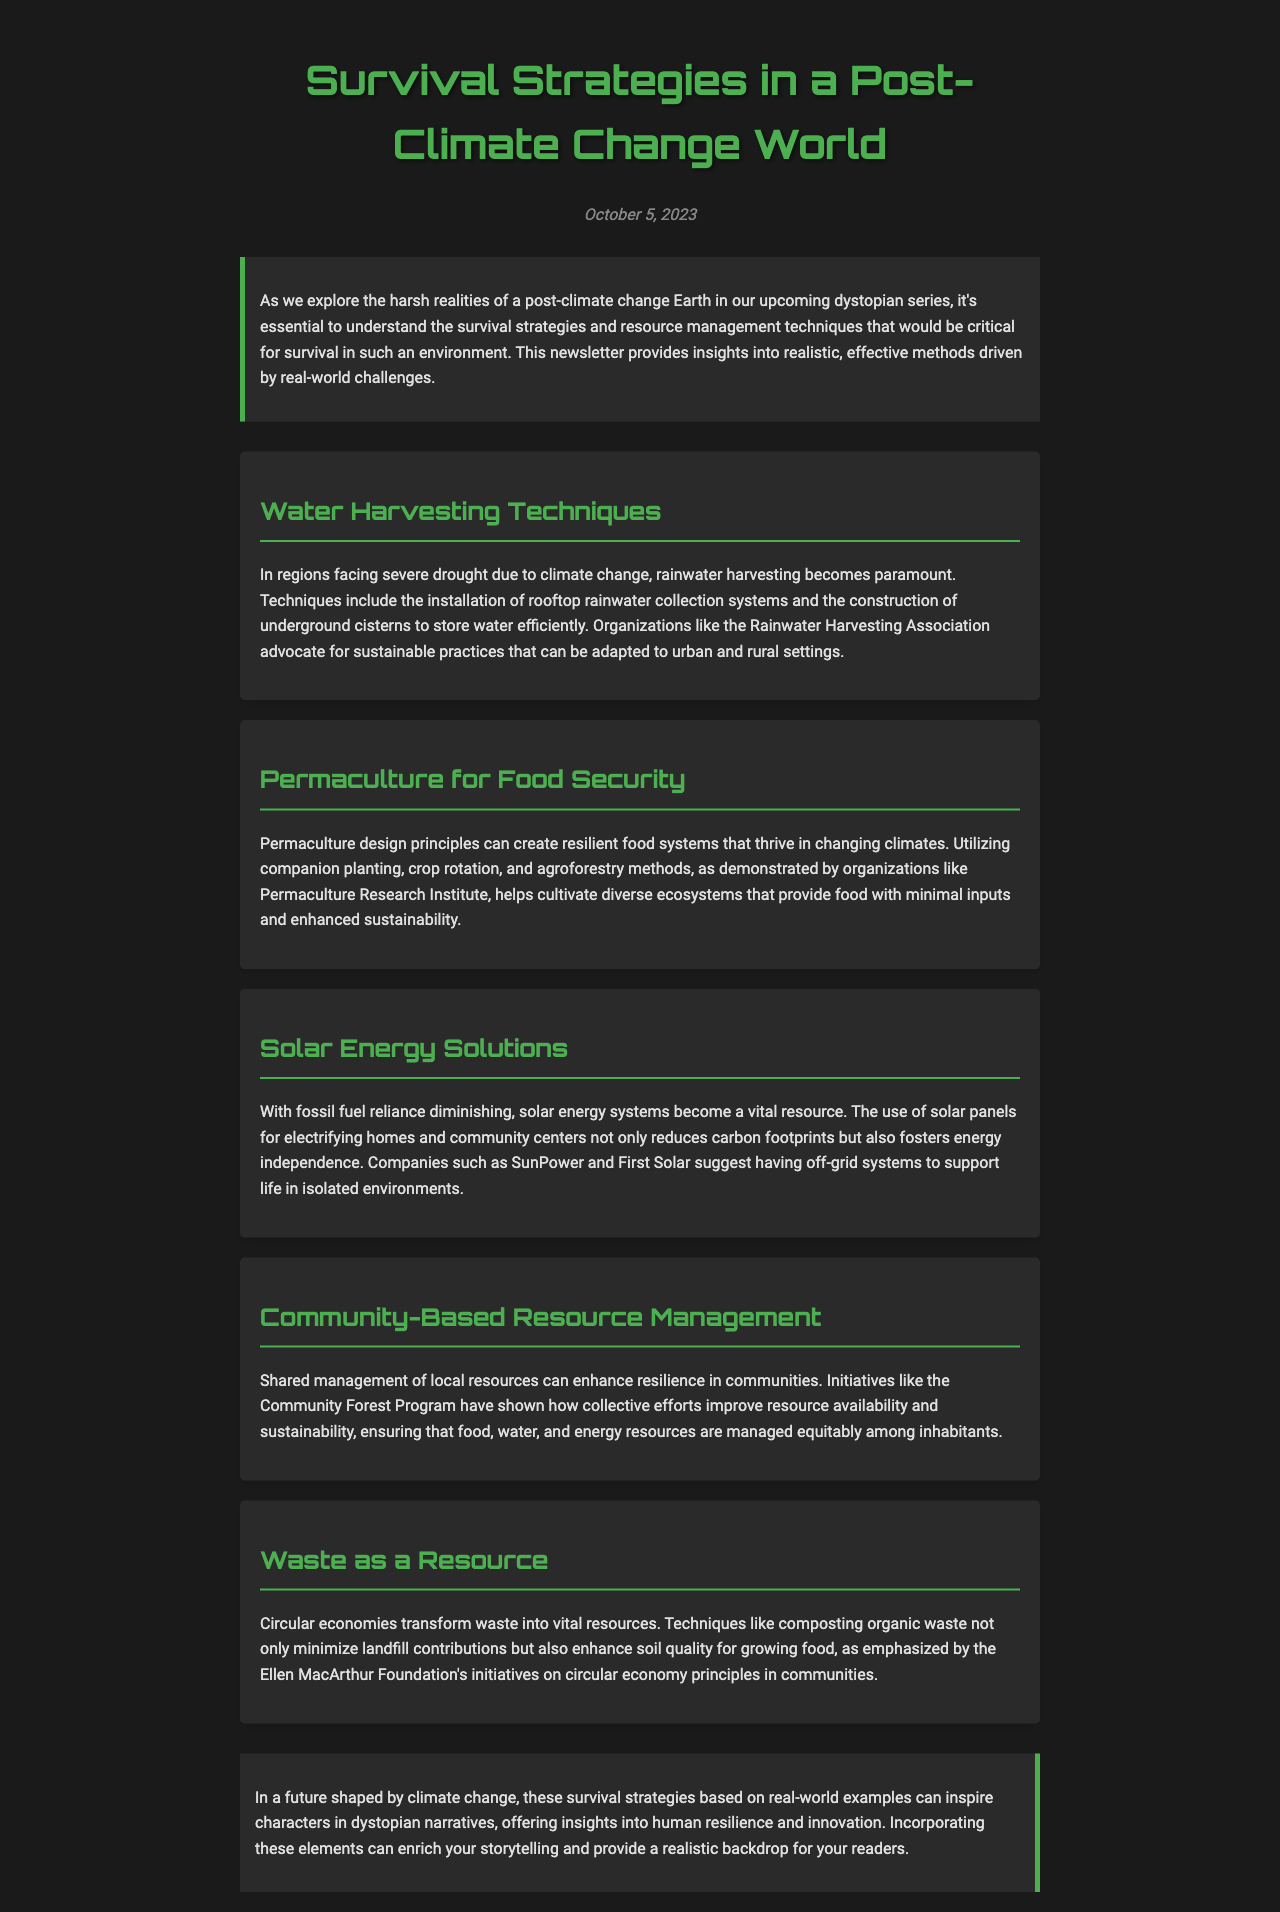What is the title of the newsletter? The title of the newsletter is presented prominently at the top of the document.
Answer: Survival Strategies in a Post-Climate Change World What is the date of the newsletter? The date is mentioned right below the title in italics.
Answer: October 5, 2023 What technique is emphasized for water harvesting? The document highlights specific methods for collecting water in drought-affected areas.
Answer: Rainwater harvesting Which agricultural method is discussed for food security? The section describes a method that involves sustainable farming practices.
Answer: Permaculture What energy solution is suggested in the newsletter? The document states a resource that is essential for reducing reliance on fossil fuels.
Answer: Solar energy What type of management is advocated for local resources? The document suggests a cooperative approach to managing communal assets.
Answer: Community-Based Resource Management What does circular economy transform? The newsletter explains a principle that reuses materials rather than discarding them.
Answer: Waste What organization is cited for promoting rainwater harvesting? The document refers to a specific association focused on sustainable water practices.
Answer: Rainwater Harvesting Association How does composting benefit the soil? The document outlines a method that improves soil health through recycling organic matter.
Answer: Enhances soil quality 